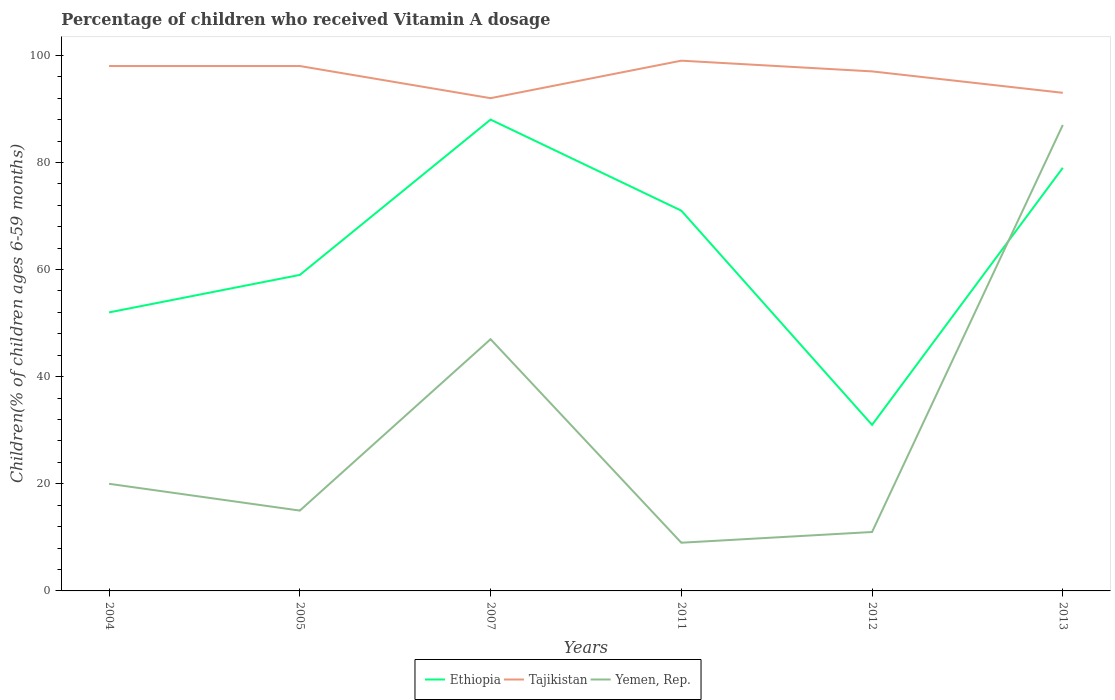How many different coloured lines are there?
Your response must be concise. 3. Does the line corresponding to Yemen, Rep. intersect with the line corresponding to Ethiopia?
Give a very brief answer. Yes. Is the number of lines equal to the number of legend labels?
Offer a terse response. Yes. Across all years, what is the maximum percentage of children who received Vitamin A dosage in Ethiopia?
Your answer should be very brief. 31. What is the total percentage of children who received Vitamin A dosage in Ethiopia in the graph?
Offer a very short reply. -8. How many years are there in the graph?
Your answer should be compact. 6. What is the difference between two consecutive major ticks on the Y-axis?
Your response must be concise. 20. Are the values on the major ticks of Y-axis written in scientific E-notation?
Your answer should be compact. No. Does the graph contain any zero values?
Provide a short and direct response. No. How many legend labels are there?
Offer a very short reply. 3. What is the title of the graph?
Make the answer very short. Percentage of children who received Vitamin A dosage. What is the label or title of the Y-axis?
Make the answer very short. Children(% of children ages 6-59 months). What is the Children(% of children ages 6-59 months) of Ethiopia in 2004?
Provide a succinct answer. 52. What is the Children(% of children ages 6-59 months) in Tajikistan in 2005?
Ensure brevity in your answer.  98. What is the Children(% of children ages 6-59 months) in Yemen, Rep. in 2005?
Keep it short and to the point. 15. What is the Children(% of children ages 6-59 months) of Ethiopia in 2007?
Keep it short and to the point. 88. What is the Children(% of children ages 6-59 months) in Tajikistan in 2007?
Your answer should be very brief. 92. What is the Children(% of children ages 6-59 months) of Ethiopia in 2011?
Your response must be concise. 71. What is the Children(% of children ages 6-59 months) of Tajikistan in 2011?
Provide a succinct answer. 99. What is the Children(% of children ages 6-59 months) of Ethiopia in 2012?
Offer a very short reply. 31. What is the Children(% of children ages 6-59 months) of Tajikistan in 2012?
Ensure brevity in your answer.  97. What is the Children(% of children ages 6-59 months) of Ethiopia in 2013?
Provide a succinct answer. 79. What is the Children(% of children ages 6-59 months) of Tajikistan in 2013?
Your response must be concise. 93. Across all years, what is the maximum Children(% of children ages 6-59 months) of Ethiopia?
Keep it short and to the point. 88. Across all years, what is the maximum Children(% of children ages 6-59 months) in Yemen, Rep.?
Make the answer very short. 87. Across all years, what is the minimum Children(% of children ages 6-59 months) in Ethiopia?
Offer a terse response. 31. Across all years, what is the minimum Children(% of children ages 6-59 months) in Tajikistan?
Ensure brevity in your answer.  92. Across all years, what is the minimum Children(% of children ages 6-59 months) of Yemen, Rep.?
Keep it short and to the point. 9. What is the total Children(% of children ages 6-59 months) in Ethiopia in the graph?
Your answer should be very brief. 380. What is the total Children(% of children ages 6-59 months) of Tajikistan in the graph?
Your response must be concise. 577. What is the total Children(% of children ages 6-59 months) in Yemen, Rep. in the graph?
Offer a terse response. 189. What is the difference between the Children(% of children ages 6-59 months) in Ethiopia in 2004 and that in 2005?
Make the answer very short. -7. What is the difference between the Children(% of children ages 6-59 months) in Tajikistan in 2004 and that in 2005?
Your answer should be compact. 0. What is the difference between the Children(% of children ages 6-59 months) in Ethiopia in 2004 and that in 2007?
Provide a short and direct response. -36. What is the difference between the Children(% of children ages 6-59 months) of Yemen, Rep. in 2004 and that in 2007?
Provide a succinct answer. -27. What is the difference between the Children(% of children ages 6-59 months) of Yemen, Rep. in 2004 and that in 2011?
Make the answer very short. 11. What is the difference between the Children(% of children ages 6-59 months) in Ethiopia in 2004 and that in 2012?
Provide a succinct answer. 21. What is the difference between the Children(% of children ages 6-59 months) in Tajikistan in 2004 and that in 2012?
Keep it short and to the point. 1. What is the difference between the Children(% of children ages 6-59 months) in Ethiopia in 2004 and that in 2013?
Keep it short and to the point. -27. What is the difference between the Children(% of children ages 6-59 months) in Yemen, Rep. in 2004 and that in 2013?
Your answer should be compact. -67. What is the difference between the Children(% of children ages 6-59 months) of Yemen, Rep. in 2005 and that in 2007?
Provide a short and direct response. -32. What is the difference between the Children(% of children ages 6-59 months) in Yemen, Rep. in 2005 and that in 2011?
Give a very brief answer. 6. What is the difference between the Children(% of children ages 6-59 months) of Tajikistan in 2005 and that in 2012?
Your answer should be very brief. 1. What is the difference between the Children(% of children ages 6-59 months) of Yemen, Rep. in 2005 and that in 2012?
Ensure brevity in your answer.  4. What is the difference between the Children(% of children ages 6-59 months) of Yemen, Rep. in 2005 and that in 2013?
Offer a very short reply. -72. What is the difference between the Children(% of children ages 6-59 months) in Tajikistan in 2007 and that in 2011?
Your response must be concise. -7. What is the difference between the Children(% of children ages 6-59 months) of Yemen, Rep. in 2007 and that in 2011?
Offer a terse response. 38. What is the difference between the Children(% of children ages 6-59 months) in Ethiopia in 2007 and that in 2012?
Your answer should be compact. 57. What is the difference between the Children(% of children ages 6-59 months) in Tajikistan in 2007 and that in 2012?
Offer a very short reply. -5. What is the difference between the Children(% of children ages 6-59 months) of Yemen, Rep. in 2007 and that in 2012?
Make the answer very short. 36. What is the difference between the Children(% of children ages 6-59 months) of Ethiopia in 2007 and that in 2013?
Ensure brevity in your answer.  9. What is the difference between the Children(% of children ages 6-59 months) in Ethiopia in 2011 and that in 2012?
Offer a terse response. 40. What is the difference between the Children(% of children ages 6-59 months) in Tajikistan in 2011 and that in 2012?
Make the answer very short. 2. What is the difference between the Children(% of children ages 6-59 months) of Yemen, Rep. in 2011 and that in 2012?
Give a very brief answer. -2. What is the difference between the Children(% of children ages 6-59 months) of Yemen, Rep. in 2011 and that in 2013?
Give a very brief answer. -78. What is the difference between the Children(% of children ages 6-59 months) in Ethiopia in 2012 and that in 2013?
Your answer should be compact. -48. What is the difference between the Children(% of children ages 6-59 months) in Tajikistan in 2012 and that in 2013?
Ensure brevity in your answer.  4. What is the difference between the Children(% of children ages 6-59 months) in Yemen, Rep. in 2012 and that in 2013?
Your answer should be compact. -76. What is the difference between the Children(% of children ages 6-59 months) of Ethiopia in 2004 and the Children(% of children ages 6-59 months) of Tajikistan in 2005?
Provide a short and direct response. -46. What is the difference between the Children(% of children ages 6-59 months) of Ethiopia in 2004 and the Children(% of children ages 6-59 months) of Yemen, Rep. in 2005?
Ensure brevity in your answer.  37. What is the difference between the Children(% of children ages 6-59 months) of Tajikistan in 2004 and the Children(% of children ages 6-59 months) of Yemen, Rep. in 2005?
Offer a very short reply. 83. What is the difference between the Children(% of children ages 6-59 months) in Ethiopia in 2004 and the Children(% of children ages 6-59 months) in Tajikistan in 2007?
Your answer should be very brief. -40. What is the difference between the Children(% of children ages 6-59 months) of Ethiopia in 2004 and the Children(% of children ages 6-59 months) of Tajikistan in 2011?
Ensure brevity in your answer.  -47. What is the difference between the Children(% of children ages 6-59 months) in Ethiopia in 2004 and the Children(% of children ages 6-59 months) in Yemen, Rep. in 2011?
Give a very brief answer. 43. What is the difference between the Children(% of children ages 6-59 months) in Tajikistan in 2004 and the Children(% of children ages 6-59 months) in Yemen, Rep. in 2011?
Your answer should be compact. 89. What is the difference between the Children(% of children ages 6-59 months) of Ethiopia in 2004 and the Children(% of children ages 6-59 months) of Tajikistan in 2012?
Provide a short and direct response. -45. What is the difference between the Children(% of children ages 6-59 months) of Tajikistan in 2004 and the Children(% of children ages 6-59 months) of Yemen, Rep. in 2012?
Keep it short and to the point. 87. What is the difference between the Children(% of children ages 6-59 months) of Ethiopia in 2004 and the Children(% of children ages 6-59 months) of Tajikistan in 2013?
Provide a succinct answer. -41. What is the difference between the Children(% of children ages 6-59 months) in Ethiopia in 2004 and the Children(% of children ages 6-59 months) in Yemen, Rep. in 2013?
Provide a succinct answer. -35. What is the difference between the Children(% of children ages 6-59 months) of Ethiopia in 2005 and the Children(% of children ages 6-59 months) of Tajikistan in 2007?
Keep it short and to the point. -33. What is the difference between the Children(% of children ages 6-59 months) of Ethiopia in 2005 and the Children(% of children ages 6-59 months) of Yemen, Rep. in 2007?
Keep it short and to the point. 12. What is the difference between the Children(% of children ages 6-59 months) in Ethiopia in 2005 and the Children(% of children ages 6-59 months) in Tajikistan in 2011?
Make the answer very short. -40. What is the difference between the Children(% of children ages 6-59 months) of Tajikistan in 2005 and the Children(% of children ages 6-59 months) of Yemen, Rep. in 2011?
Give a very brief answer. 89. What is the difference between the Children(% of children ages 6-59 months) in Ethiopia in 2005 and the Children(% of children ages 6-59 months) in Tajikistan in 2012?
Provide a short and direct response. -38. What is the difference between the Children(% of children ages 6-59 months) of Ethiopia in 2005 and the Children(% of children ages 6-59 months) of Yemen, Rep. in 2012?
Offer a very short reply. 48. What is the difference between the Children(% of children ages 6-59 months) of Ethiopia in 2005 and the Children(% of children ages 6-59 months) of Tajikistan in 2013?
Provide a short and direct response. -34. What is the difference between the Children(% of children ages 6-59 months) in Ethiopia in 2005 and the Children(% of children ages 6-59 months) in Yemen, Rep. in 2013?
Ensure brevity in your answer.  -28. What is the difference between the Children(% of children ages 6-59 months) in Tajikistan in 2005 and the Children(% of children ages 6-59 months) in Yemen, Rep. in 2013?
Your response must be concise. 11. What is the difference between the Children(% of children ages 6-59 months) in Ethiopia in 2007 and the Children(% of children ages 6-59 months) in Tajikistan in 2011?
Provide a succinct answer. -11. What is the difference between the Children(% of children ages 6-59 months) in Ethiopia in 2007 and the Children(% of children ages 6-59 months) in Yemen, Rep. in 2011?
Keep it short and to the point. 79. What is the difference between the Children(% of children ages 6-59 months) in Tajikistan in 2007 and the Children(% of children ages 6-59 months) in Yemen, Rep. in 2012?
Your answer should be very brief. 81. What is the difference between the Children(% of children ages 6-59 months) of Ethiopia in 2011 and the Children(% of children ages 6-59 months) of Tajikistan in 2012?
Offer a terse response. -26. What is the difference between the Children(% of children ages 6-59 months) in Ethiopia in 2011 and the Children(% of children ages 6-59 months) in Yemen, Rep. in 2012?
Provide a short and direct response. 60. What is the difference between the Children(% of children ages 6-59 months) in Tajikistan in 2011 and the Children(% of children ages 6-59 months) in Yemen, Rep. in 2012?
Offer a terse response. 88. What is the difference between the Children(% of children ages 6-59 months) in Tajikistan in 2011 and the Children(% of children ages 6-59 months) in Yemen, Rep. in 2013?
Make the answer very short. 12. What is the difference between the Children(% of children ages 6-59 months) of Ethiopia in 2012 and the Children(% of children ages 6-59 months) of Tajikistan in 2013?
Give a very brief answer. -62. What is the difference between the Children(% of children ages 6-59 months) in Ethiopia in 2012 and the Children(% of children ages 6-59 months) in Yemen, Rep. in 2013?
Offer a terse response. -56. What is the average Children(% of children ages 6-59 months) of Ethiopia per year?
Provide a short and direct response. 63.33. What is the average Children(% of children ages 6-59 months) of Tajikistan per year?
Make the answer very short. 96.17. What is the average Children(% of children ages 6-59 months) of Yemen, Rep. per year?
Offer a very short reply. 31.5. In the year 2004, what is the difference between the Children(% of children ages 6-59 months) of Ethiopia and Children(% of children ages 6-59 months) of Tajikistan?
Offer a terse response. -46. In the year 2004, what is the difference between the Children(% of children ages 6-59 months) of Ethiopia and Children(% of children ages 6-59 months) of Yemen, Rep.?
Provide a succinct answer. 32. In the year 2005, what is the difference between the Children(% of children ages 6-59 months) of Ethiopia and Children(% of children ages 6-59 months) of Tajikistan?
Your answer should be very brief. -39. In the year 2005, what is the difference between the Children(% of children ages 6-59 months) in Ethiopia and Children(% of children ages 6-59 months) in Yemen, Rep.?
Offer a terse response. 44. In the year 2005, what is the difference between the Children(% of children ages 6-59 months) of Tajikistan and Children(% of children ages 6-59 months) of Yemen, Rep.?
Make the answer very short. 83. In the year 2012, what is the difference between the Children(% of children ages 6-59 months) in Ethiopia and Children(% of children ages 6-59 months) in Tajikistan?
Provide a succinct answer. -66. In the year 2012, what is the difference between the Children(% of children ages 6-59 months) of Ethiopia and Children(% of children ages 6-59 months) of Yemen, Rep.?
Provide a succinct answer. 20. In the year 2012, what is the difference between the Children(% of children ages 6-59 months) in Tajikistan and Children(% of children ages 6-59 months) in Yemen, Rep.?
Give a very brief answer. 86. In the year 2013, what is the difference between the Children(% of children ages 6-59 months) of Ethiopia and Children(% of children ages 6-59 months) of Tajikistan?
Your answer should be very brief. -14. In the year 2013, what is the difference between the Children(% of children ages 6-59 months) of Tajikistan and Children(% of children ages 6-59 months) of Yemen, Rep.?
Give a very brief answer. 6. What is the ratio of the Children(% of children ages 6-59 months) in Ethiopia in 2004 to that in 2005?
Your answer should be compact. 0.88. What is the ratio of the Children(% of children ages 6-59 months) in Tajikistan in 2004 to that in 2005?
Ensure brevity in your answer.  1. What is the ratio of the Children(% of children ages 6-59 months) of Ethiopia in 2004 to that in 2007?
Your response must be concise. 0.59. What is the ratio of the Children(% of children ages 6-59 months) in Tajikistan in 2004 to that in 2007?
Give a very brief answer. 1.07. What is the ratio of the Children(% of children ages 6-59 months) of Yemen, Rep. in 2004 to that in 2007?
Ensure brevity in your answer.  0.43. What is the ratio of the Children(% of children ages 6-59 months) of Ethiopia in 2004 to that in 2011?
Give a very brief answer. 0.73. What is the ratio of the Children(% of children ages 6-59 months) of Yemen, Rep. in 2004 to that in 2011?
Your answer should be compact. 2.22. What is the ratio of the Children(% of children ages 6-59 months) in Ethiopia in 2004 to that in 2012?
Your response must be concise. 1.68. What is the ratio of the Children(% of children ages 6-59 months) of Tajikistan in 2004 to that in 2012?
Ensure brevity in your answer.  1.01. What is the ratio of the Children(% of children ages 6-59 months) of Yemen, Rep. in 2004 to that in 2012?
Your answer should be compact. 1.82. What is the ratio of the Children(% of children ages 6-59 months) of Ethiopia in 2004 to that in 2013?
Provide a short and direct response. 0.66. What is the ratio of the Children(% of children ages 6-59 months) of Tajikistan in 2004 to that in 2013?
Ensure brevity in your answer.  1.05. What is the ratio of the Children(% of children ages 6-59 months) of Yemen, Rep. in 2004 to that in 2013?
Ensure brevity in your answer.  0.23. What is the ratio of the Children(% of children ages 6-59 months) of Ethiopia in 2005 to that in 2007?
Ensure brevity in your answer.  0.67. What is the ratio of the Children(% of children ages 6-59 months) in Tajikistan in 2005 to that in 2007?
Provide a succinct answer. 1.07. What is the ratio of the Children(% of children ages 6-59 months) of Yemen, Rep. in 2005 to that in 2007?
Offer a terse response. 0.32. What is the ratio of the Children(% of children ages 6-59 months) in Ethiopia in 2005 to that in 2011?
Keep it short and to the point. 0.83. What is the ratio of the Children(% of children ages 6-59 months) of Tajikistan in 2005 to that in 2011?
Make the answer very short. 0.99. What is the ratio of the Children(% of children ages 6-59 months) of Ethiopia in 2005 to that in 2012?
Offer a very short reply. 1.9. What is the ratio of the Children(% of children ages 6-59 months) in Tajikistan in 2005 to that in 2012?
Your response must be concise. 1.01. What is the ratio of the Children(% of children ages 6-59 months) of Yemen, Rep. in 2005 to that in 2012?
Your answer should be very brief. 1.36. What is the ratio of the Children(% of children ages 6-59 months) of Ethiopia in 2005 to that in 2013?
Keep it short and to the point. 0.75. What is the ratio of the Children(% of children ages 6-59 months) in Tajikistan in 2005 to that in 2013?
Provide a succinct answer. 1.05. What is the ratio of the Children(% of children ages 6-59 months) in Yemen, Rep. in 2005 to that in 2013?
Keep it short and to the point. 0.17. What is the ratio of the Children(% of children ages 6-59 months) in Ethiopia in 2007 to that in 2011?
Your response must be concise. 1.24. What is the ratio of the Children(% of children ages 6-59 months) in Tajikistan in 2007 to that in 2011?
Keep it short and to the point. 0.93. What is the ratio of the Children(% of children ages 6-59 months) of Yemen, Rep. in 2007 to that in 2011?
Make the answer very short. 5.22. What is the ratio of the Children(% of children ages 6-59 months) in Ethiopia in 2007 to that in 2012?
Your response must be concise. 2.84. What is the ratio of the Children(% of children ages 6-59 months) in Tajikistan in 2007 to that in 2012?
Give a very brief answer. 0.95. What is the ratio of the Children(% of children ages 6-59 months) in Yemen, Rep. in 2007 to that in 2012?
Provide a succinct answer. 4.27. What is the ratio of the Children(% of children ages 6-59 months) of Ethiopia in 2007 to that in 2013?
Offer a terse response. 1.11. What is the ratio of the Children(% of children ages 6-59 months) in Tajikistan in 2007 to that in 2013?
Keep it short and to the point. 0.99. What is the ratio of the Children(% of children ages 6-59 months) of Yemen, Rep. in 2007 to that in 2013?
Your answer should be very brief. 0.54. What is the ratio of the Children(% of children ages 6-59 months) in Ethiopia in 2011 to that in 2012?
Your answer should be compact. 2.29. What is the ratio of the Children(% of children ages 6-59 months) of Tajikistan in 2011 to that in 2012?
Offer a very short reply. 1.02. What is the ratio of the Children(% of children ages 6-59 months) in Yemen, Rep. in 2011 to that in 2012?
Make the answer very short. 0.82. What is the ratio of the Children(% of children ages 6-59 months) in Ethiopia in 2011 to that in 2013?
Make the answer very short. 0.9. What is the ratio of the Children(% of children ages 6-59 months) of Tajikistan in 2011 to that in 2013?
Make the answer very short. 1.06. What is the ratio of the Children(% of children ages 6-59 months) of Yemen, Rep. in 2011 to that in 2013?
Provide a succinct answer. 0.1. What is the ratio of the Children(% of children ages 6-59 months) in Ethiopia in 2012 to that in 2013?
Offer a terse response. 0.39. What is the ratio of the Children(% of children ages 6-59 months) in Tajikistan in 2012 to that in 2013?
Provide a succinct answer. 1.04. What is the ratio of the Children(% of children ages 6-59 months) in Yemen, Rep. in 2012 to that in 2013?
Offer a very short reply. 0.13. What is the difference between the highest and the second highest Children(% of children ages 6-59 months) in Ethiopia?
Provide a succinct answer. 9. What is the difference between the highest and the second highest Children(% of children ages 6-59 months) in Tajikistan?
Offer a very short reply. 1. What is the difference between the highest and the second highest Children(% of children ages 6-59 months) in Yemen, Rep.?
Offer a very short reply. 40. What is the difference between the highest and the lowest Children(% of children ages 6-59 months) in Tajikistan?
Give a very brief answer. 7. 